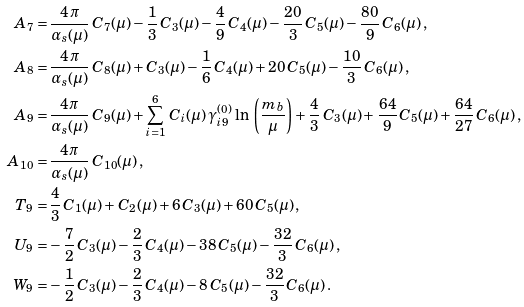<formula> <loc_0><loc_0><loc_500><loc_500>A _ { 7 } = & \, \frac { 4 \, \pi } { \alpha _ { s } ( \mu ) } \, C _ { 7 } ( \mu ) - \frac { 1 } { 3 } \, C _ { 3 } ( \mu ) - \frac { 4 } { 9 } \, C _ { 4 } ( \mu ) - \frac { 2 0 } { 3 } \, C _ { 5 } ( \mu ) - \frac { 8 0 } { 9 } \, C _ { 6 } ( \mu ) \, , \\ A _ { 8 } = & \, \frac { 4 \, \pi } { \alpha _ { s } ( \mu ) } \, C _ { 8 } ( \mu ) + C _ { 3 } ( \mu ) - \frac { 1 } { 6 } \, C _ { 4 } ( \mu ) + 2 0 \, C _ { 5 } ( \mu ) - \frac { 1 0 } { 3 } \, C _ { 6 } ( \mu ) \, , \\ A _ { 9 } = & \, \frac { 4 \pi } { \alpha _ { s } ( \mu ) } \, C _ { 9 } ( \mu ) + \sum _ { i = 1 } ^ { 6 } \, C _ { i } ( \mu ) \, \gamma _ { i 9 } ^ { ( 0 ) } \, \ln \, \left ( \frac { m _ { b } } { \mu } \right ) + \frac { 4 } { 3 } \, C _ { 3 } ( \mu ) + \frac { 6 4 } { 9 } \, C _ { 5 } ( \mu ) + \frac { 6 4 } { 2 7 } \, C _ { 6 } ( \mu ) \, , \\ A _ { 1 0 } = & \, \frac { 4 \pi } { \alpha _ { s } ( \mu ) } \, C _ { 1 0 } ( \mu ) \, , \\ T _ { 9 } = & \, \frac { 4 } { 3 } \, C _ { 1 } ( \mu ) + C _ { 2 } ( \mu ) + 6 \, C _ { 3 } ( \mu ) + 6 0 \, C _ { 5 } ( \mu ) \, , \\ U _ { 9 } = & - \frac { 7 } { 2 } \, C _ { 3 } ( \mu ) - \frac { 2 } { 3 } \, C _ { 4 } ( \mu ) - 3 8 \, C _ { 5 } ( \mu ) - \frac { 3 2 } { 3 } \, C _ { 6 } ( \mu ) \, , \\ W _ { 9 } = & - \frac { 1 } { 2 } \, C _ { 3 } ( \mu ) - \frac { 2 } { 3 } \, C _ { 4 } ( \mu ) - 8 \, C _ { 5 } ( \mu ) - \frac { 3 2 } { 3 } \, C _ { 6 } ( \mu ) \, .</formula> 